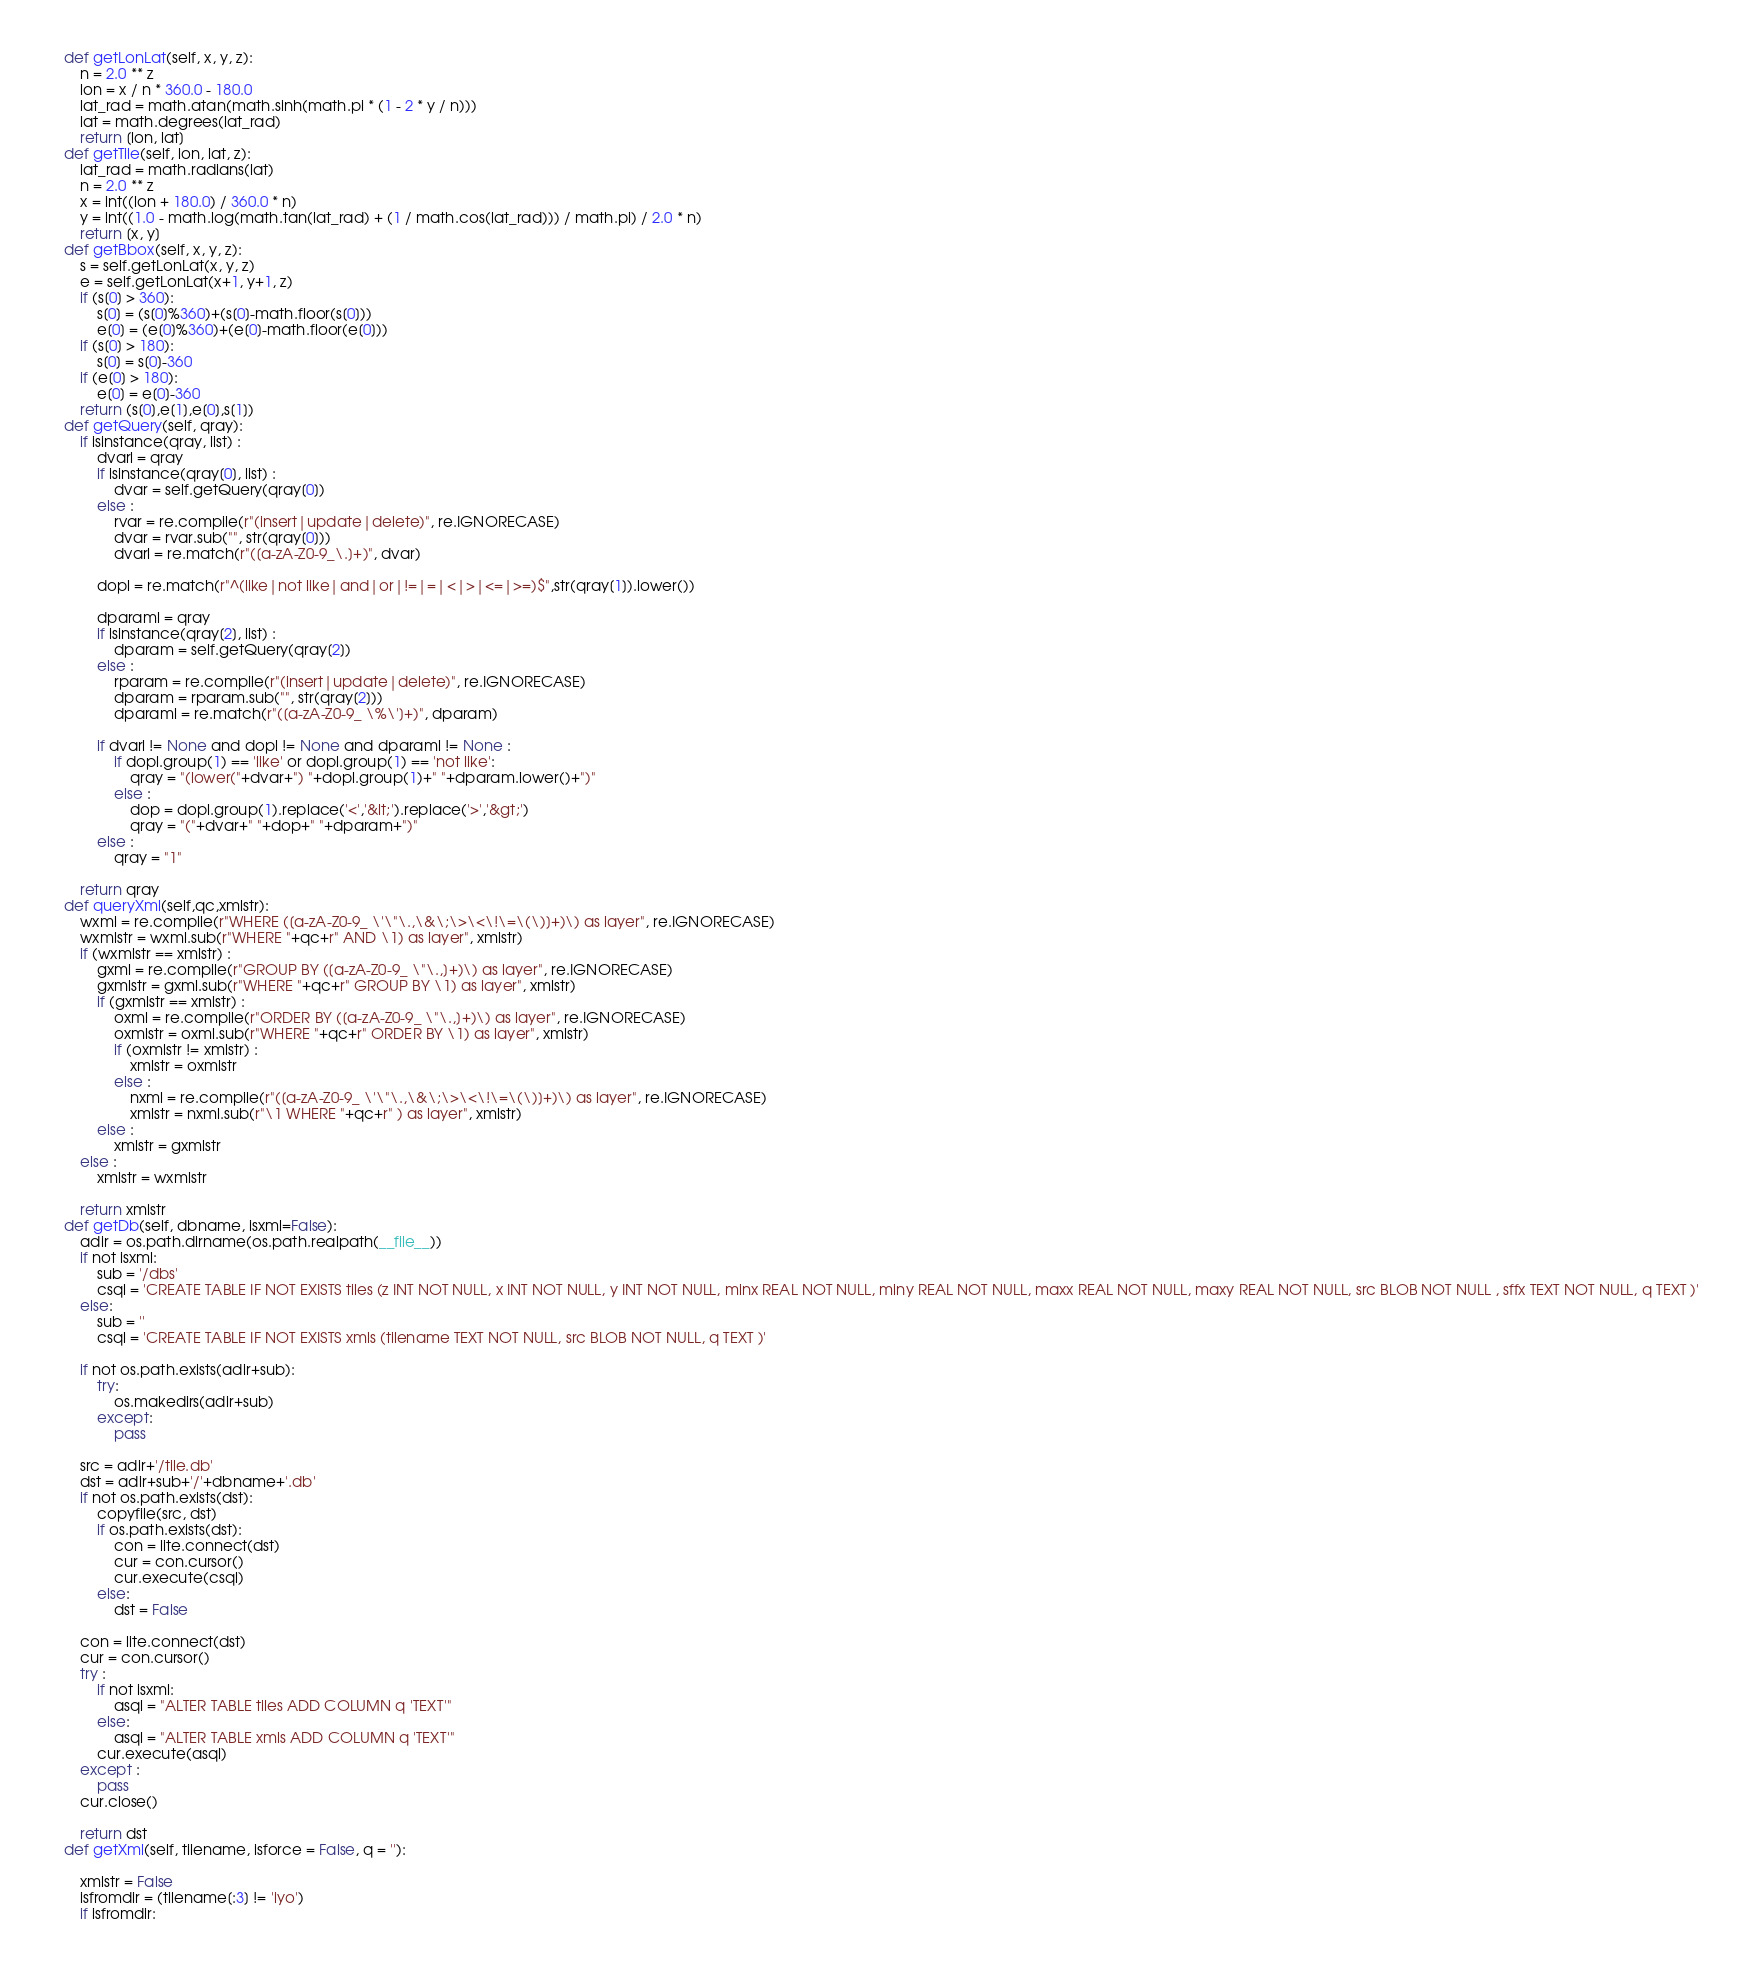<code> <loc_0><loc_0><loc_500><loc_500><_Python_>	def getLonLat(self, x, y, z):
		n = 2.0 ** z
		lon = x / n * 360.0 - 180.0
		lat_rad = math.atan(math.sinh(math.pi * (1 - 2 * y / n)))
		lat = math.degrees(lat_rad)
		return [lon, lat]
	def getTile(self, lon, lat, z):
		lat_rad = math.radians(lat)
		n = 2.0 ** z
		x = int((lon + 180.0) / 360.0 * n)
		y = int((1.0 - math.log(math.tan(lat_rad) + (1 / math.cos(lat_rad))) / math.pi) / 2.0 * n)
		return [x, y]
	def getBbox(self, x, y, z):		
		s = self.getLonLat(x, y, z)
		e = self.getLonLat(x+1, y+1, z)
		if (s[0] > 360):
			s[0] = (s[0]%360)+(s[0]-math.floor(s[0]))
			e[0] = (e[0]%360)+(e[0]-math.floor(e[0]))		
		if (s[0] > 180):
			s[0] = s[0]-360			
		if (e[0] > 180):
			e[0] = e[0]-360		
		return (s[0],e[1],e[0],s[1])
	def getQuery(self, qray):			
		if isinstance(qray, list) :
			dvarl = qray
			if isinstance(qray[0], list) :
				dvar = self.getQuery(qray[0])
			else :					
				rvar = re.compile(r"(insert|update|delete)", re.IGNORECASE)
				dvar = rvar.sub("", str(qray[0]))				
				dvarl = re.match(r"([a-zA-Z0-9_\.]+)", dvar)			
						
			dopl = re.match(r"^(like|not like|and|or|!=|=|<|>|<=|>=)$",str(qray[1]).lower())
			
			dparaml = qray
			if isinstance(qray[2], list) :
				dparam = self.getQuery(qray[2])
			else :					
				rparam = re.compile(r"(insert|update|delete)", re.IGNORECASE)
				dparam = rparam.sub("", str(qray[2]))
				dparaml = re.match(r"([a-zA-Z0-9_ \%\']+)", dparam)																		
			
			if dvarl != None and dopl != None and dparaml != None :
				if dopl.group(1) == 'like' or dopl.group(1) == 'not like':
					qray = "(lower("+dvar+") "+dopl.group(1)+" "+dparam.lower()+")"								
				else :	
					dop = dopl.group(1).replace('<','&lt;').replace('>','&gt;')	
					qray = "("+dvar+" "+dop+" "+dparam+")"				
			else :
				qray = "1"
					
		return qray
	def queryXml(self,qc,xmlstr):
		wxml = re.compile(r"WHERE ([a-zA-Z0-9_ \'\"\.,\&\;\>\<\!\=\(\)]+)\) as layer", re.IGNORECASE)								
		wxmlstr = wxml.sub(r"WHERE "+qc+r" AND \1) as layer", xmlstr)																																									
		if (wxmlstr == xmlstr) :
			gxml = re.compile(r"GROUP BY ([a-zA-Z0-9_ \"\.,]+)\) as layer", re.IGNORECASE)								
			gxmlstr = gxml.sub(r"WHERE "+qc+r" GROUP BY \1) as layer", xmlstr)																																										
			if (gxmlstr == xmlstr) :
				oxml = re.compile(r"ORDER BY ([a-zA-Z0-9_ \"\.,]+)\) as layer", re.IGNORECASE)								
				oxmlstr = oxml.sub(r"WHERE "+qc+r" ORDER BY \1) as layer", xmlstr)																																												
				if (oxmlstr != xmlstr) :
					xmlstr = oxmlstr
				else :
					nxml = re.compile(r"([a-zA-Z0-9_ \'\"\.,\&\;\>\<\!\=\(\)]+)\) as layer", re.IGNORECASE)								
					xmlstr = nxml.sub(r"\1 WHERE "+qc+r" ) as layer", xmlstr)
			else :
				xmlstr = gxmlstr	
		else :
			xmlstr = wxmlstr	
		
		return xmlstr			
	def getDb(self, dbname, isxml=False):
		adir = os.path.dirname(os.path.realpath(__file__))	
		if not isxml:
			sub = '/dbs'
			csql = 'CREATE TABLE IF NOT EXISTS tiles (z INT NOT NULL, x INT NOT NULL, y INT NOT NULL, minx REAL NOT NULL, miny REAL NOT NULL, maxx REAL NOT NULL, maxy REAL NOT NULL, src BLOB NOT NULL , sffx TEXT NOT NULL, q TEXT )'
		else:
			sub = ''
			csql = 'CREATE TABLE IF NOT EXISTS xmls (tilename TEXT NOT NULL, src BLOB NOT NULL, q TEXT )'								
			
		if not os.path.exists(adir+sub):
			try:				
				os.makedirs(adir+sub)								
			except:
				pass
		
		src = adir+'/tile.db'
		dst = adir+sub+'/'+dbname+'.db'
		if not os.path.exists(dst):
			copyfile(src, dst)				
			if os.path.exists(dst):				
				con = lite.connect(dst)
				cur = con.cursor()    								
				cur.execute(csql)										
			else:				
				dst = False			
				
		con = lite.connect(dst)
		cur = con.cursor()    						
		try :			
			if not isxml:
				asql = "ALTER TABLE tiles ADD COLUMN q 'TEXT'"
			else:
				asql = "ALTER TABLE xmls ADD COLUMN q 'TEXT'"
			cur.execute(asql)										
		except :
			pass
		cur.close()	
			
		return dst
	def getXml(self, tilename, isforce = False, q = ''):
		
		xmlstr = False		
		isfromdir = (tilename[:3] != 'iyo')
		if isfromdir:</code> 